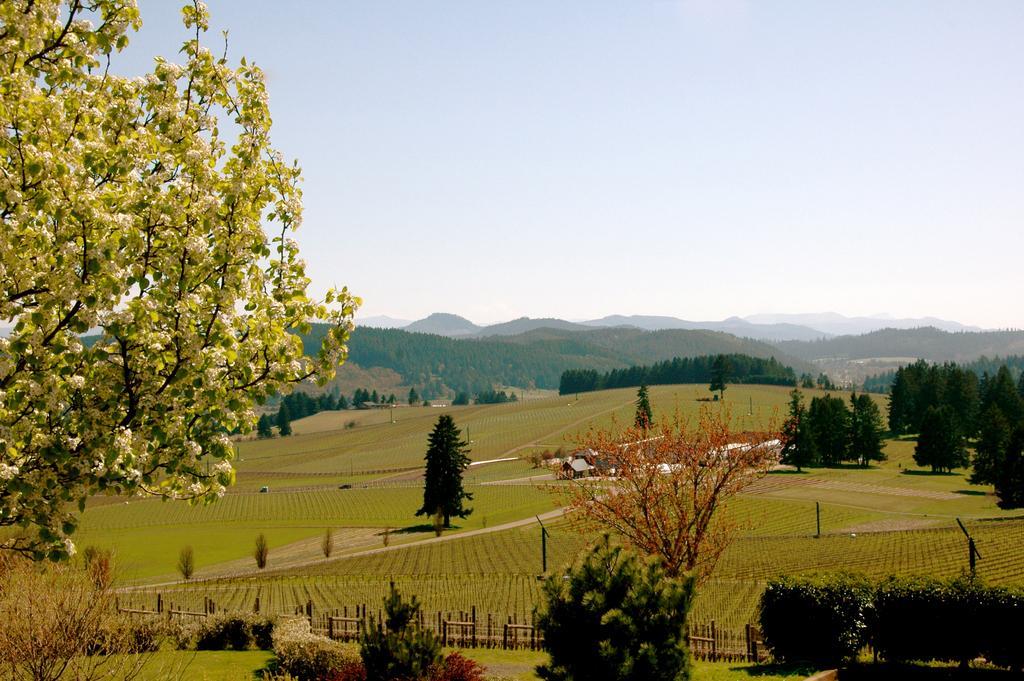How would you summarize this image in a sentence or two? In the picture we can see a scenery with plants, grass surface, trees, crops, railing, hills and sky. 